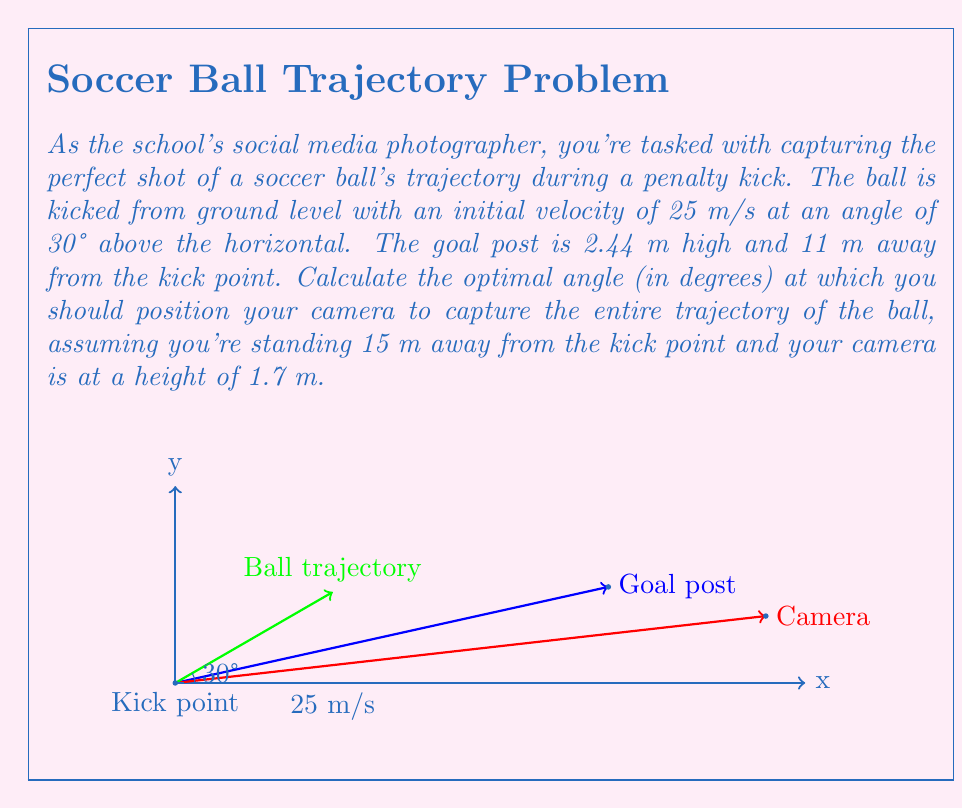Can you answer this question? To solve this problem, we need to follow these steps:

1) First, let's calculate the time it takes for the ball to reach the goal post:

   Using the horizontal component of motion: $x = v_0 \cos(\theta) t$
   $$11 = 25 \cos(30°) t$$
   $$t = \frac{11}{25 \cos(30°)} \approx 0.508 \text{ seconds}$$

2) Now, let's calculate the height of the ball when it reaches the goal post:

   Using the vertical component of motion: $y = v_0 \sin(\theta) t - \frac{1}{2}gt^2$
   $$y = 25 \sin(30°) (0.508) - \frac{1}{2}(9.8)(0.508)^2 \approx 4.92 \text{ meters}$$

3) We now have two points on the trajectory: (0, 0) and (11, 4.92)

4) The optimal camera angle would be the one that points at the highest point of the trajectory. To find this, we need to calculate the time to reach the highest point:

   $$t_{max} = \frac{v_0 \sin(\theta)}{g} = \frac{25 \sin(30°)}{9.8} \approx 0.637 \text{ seconds}$$

5) Now we can calculate the x and y coordinates of the highest point:

   $$x_{max} = v_0 \cos(\theta) t_{max} = 25 \cos(30°) (0.637) \approx 13.79 \text{ meters}$$
   $$y_{max} = v_0 \sin(\theta) t_{max} - \frac{1}{2}g(t_{max})^2 \approx 5.10 \text{ meters}$$

6) Finally, we can calculate the angle from the camera to this highest point:

   $$\tan(\alpha) = \frac{y_{max} - 1.7}{x_{max} - 15} = \frac{5.10 - 1.7}{13.79 - 15} \approx 2.8069$$

7) Therefore, the optimal angle is:

   $$\alpha = \arctan(2.8069) \approx 70.38°$$
Answer: $70.38°$ 